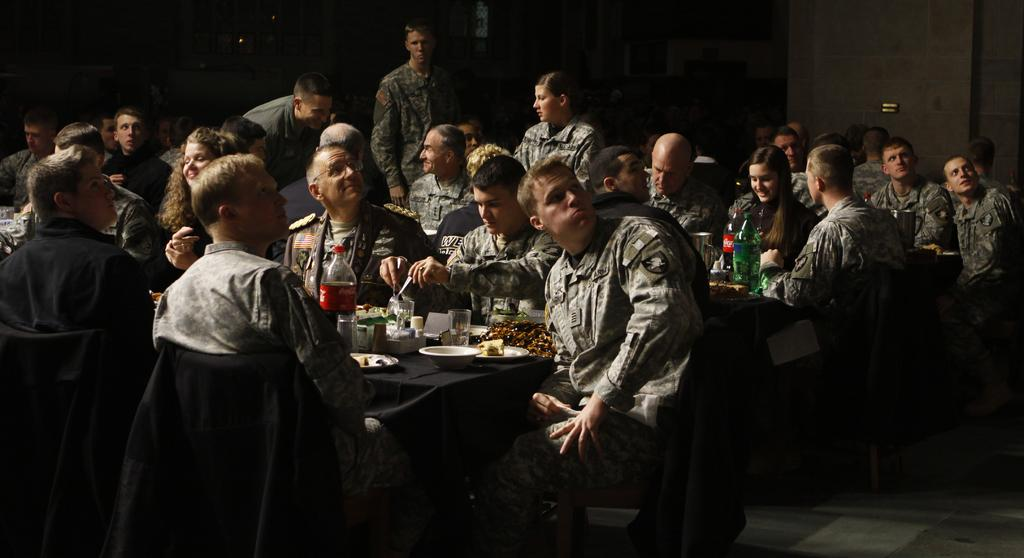What is happening in the image? There is a group of people in the image, and they are having food. How are the people positioned in the image? The people are sitting on chairs in the image. What is the arrangement of the chairs in the image? The chairs are arranged around a dining table in the image. Can you see any grass or ducks in the image? No, there is no grass or ducks present in the image. Is anyone using a hammer in the image? A: No, there is no hammer visible in the image. 